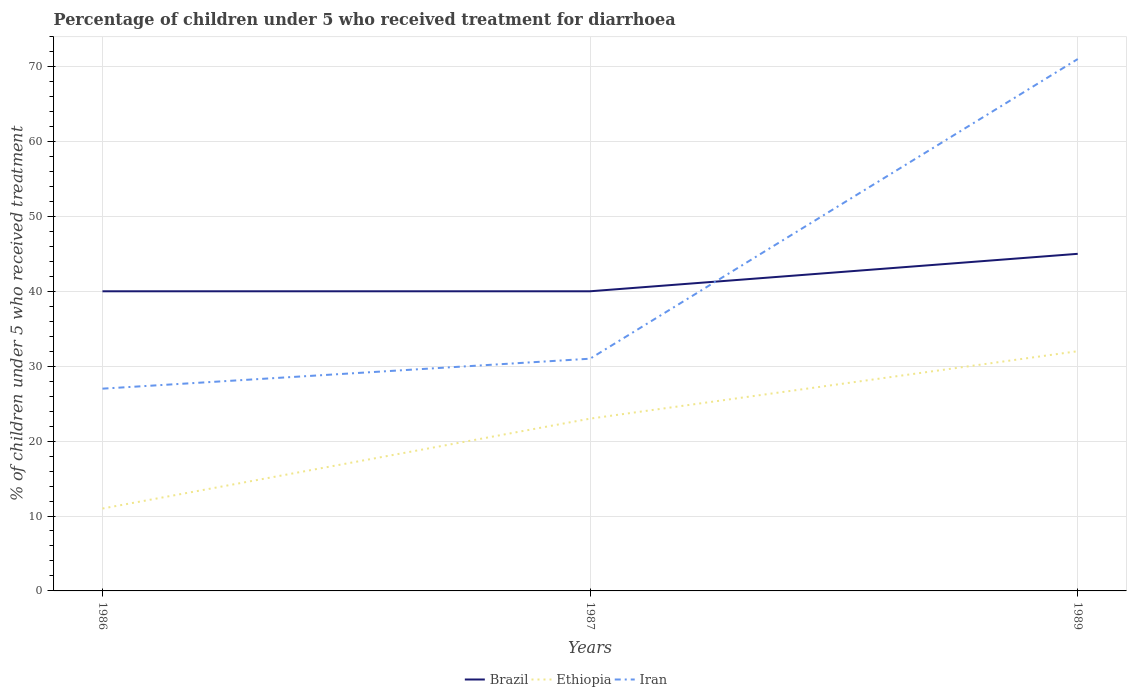How many different coloured lines are there?
Your answer should be very brief. 3. Is the number of lines equal to the number of legend labels?
Your answer should be compact. Yes. In which year was the percentage of children who received treatment for diarrhoea  in Brazil maximum?
Your answer should be compact. 1986. How many years are there in the graph?
Your response must be concise. 3. What is the difference between two consecutive major ticks on the Y-axis?
Your answer should be compact. 10. How many legend labels are there?
Your response must be concise. 3. What is the title of the graph?
Your answer should be compact. Percentage of children under 5 who received treatment for diarrhoea. What is the label or title of the X-axis?
Give a very brief answer. Years. What is the label or title of the Y-axis?
Keep it short and to the point. % of children under 5 who received treatment. What is the % of children under 5 who received treatment in Brazil in 1987?
Provide a short and direct response. 40. What is the % of children under 5 who received treatment of Ethiopia in 1987?
Make the answer very short. 23. What is the % of children under 5 who received treatment in Brazil in 1989?
Keep it short and to the point. 45. What is the % of children under 5 who received treatment in Ethiopia in 1989?
Give a very brief answer. 32. What is the % of children under 5 who received treatment of Iran in 1989?
Ensure brevity in your answer.  71. Across all years, what is the maximum % of children under 5 who received treatment in Brazil?
Your response must be concise. 45. Across all years, what is the maximum % of children under 5 who received treatment of Iran?
Your response must be concise. 71. Across all years, what is the minimum % of children under 5 who received treatment in Brazil?
Your answer should be compact. 40. What is the total % of children under 5 who received treatment in Brazil in the graph?
Your answer should be compact. 125. What is the total % of children under 5 who received treatment of Ethiopia in the graph?
Provide a succinct answer. 66. What is the total % of children under 5 who received treatment in Iran in the graph?
Provide a short and direct response. 129. What is the difference between the % of children under 5 who received treatment in Iran in 1986 and that in 1987?
Your answer should be very brief. -4. What is the difference between the % of children under 5 who received treatment of Brazil in 1986 and that in 1989?
Ensure brevity in your answer.  -5. What is the difference between the % of children under 5 who received treatment in Ethiopia in 1986 and that in 1989?
Keep it short and to the point. -21. What is the difference between the % of children under 5 who received treatment in Iran in 1986 and that in 1989?
Provide a short and direct response. -44. What is the difference between the % of children under 5 who received treatment of Ethiopia in 1987 and that in 1989?
Give a very brief answer. -9. What is the difference between the % of children under 5 who received treatment of Iran in 1987 and that in 1989?
Your response must be concise. -40. What is the difference between the % of children under 5 who received treatment of Brazil in 1986 and the % of children under 5 who received treatment of Iran in 1989?
Offer a very short reply. -31. What is the difference between the % of children under 5 who received treatment of Ethiopia in 1986 and the % of children under 5 who received treatment of Iran in 1989?
Make the answer very short. -60. What is the difference between the % of children under 5 who received treatment of Brazil in 1987 and the % of children under 5 who received treatment of Ethiopia in 1989?
Your response must be concise. 8. What is the difference between the % of children under 5 who received treatment of Brazil in 1987 and the % of children under 5 who received treatment of Iran in 1989?
Give a very brief answer. -31. What is the difference between the % of children under 5 who received treatment in Ethiopia in 1987 and the % of children under 5 who received treatment in Iran in 1989?
Ensure brevity in your answer.  -48. What is the average % of children under 5 who received treatment in Brazil per year?
Provide a succinct answer. 41.67. What is the average % of children under 5 who received treatment of Iran per year?
Your answer should be compact. 43. In the year 1986, what is the difference between the % of children under 5 who received treatment of Brazil and % of children under 5 who received treatment of Ethiopia?
Give a very brief answer. 29. In the year 1986, what is the difference between the % of children under 5 who received treatment of Ethiopia and % of children under 5 who received treatment of Iran?
Ensure brevity in your answer.  -16. In the year 1987, what is the difference between the % of children under 5 who received treatment of Brazil and % of children under 5 who received treatment of Iran?
Your response must be concise. 9. In the year 1989, what is the difference between the % of children under 5 who received treatment of Brazil and % of children under 5 who received treatment of Iran?
Provide a succinct answer. -26. In the year 1989, what is the difference between the % of children under 5 who received treatment in Ethiopia and % of children under 5 who received treatment in Iran?
Provide a short and direct response. -39. What is the ratio of the % of children under 5 who received treatment in Ethiopia in 1986 to that in 1987?
Your response must be concise. 0.48. What is the ratio of the % of children under 5 who received treatment in Iran in 1986 to that in 1987?
Your answer should be very brief. 0.87. What is the ratio of the % of children under 5 who received treatment in Brazil in 1986 to that in 1989?
Keep it short and to the point. 0.89. What is the ratio of the % of children under 5 who received treatment in Ethiopia in 1986 to that in 1989?
Offer a terse response. 0.34. What is the ratio of the % of children under 5 who received treatment in Iran in 1986 to that in 1989?
Ensure brevity in your answer.  0.38. What is the ratio of the % of children under 5 who received treatment in Brazil in 1987 to that in 1989?
Your answer should be compact. 0.89. What is the ratio of the % of children under 5 who received treatment of Ethiopia in 1987 to that in 1989?
Offer a very short reply. 0.72. What is the ratio of the % of children under 5 who received treatment of Iran in 1987 to that in 1989?
Your answer should be very brief. 0.44. What is the difference between the highest and the second highest % of children under 5 who received treatment of Ethiopia?
Your response must be concise. 9. What is the difference between the highest and the second highest % of children under 5 who received treatment in Iran?
Your answer should be compact. 40. What is the difference between the highest and the lowest % of children under 5 who received treatment of Brazil?
Offer a very short reply. 5. What is the difference between the highest and the lowest % of children under 5 who received treatment in Ethiopia?
Keep it short and to the point. 21. What is the difference between the highest and the lowest % of children under 5 who received treatment of Iran?
Keep it short and to the point. 44. 